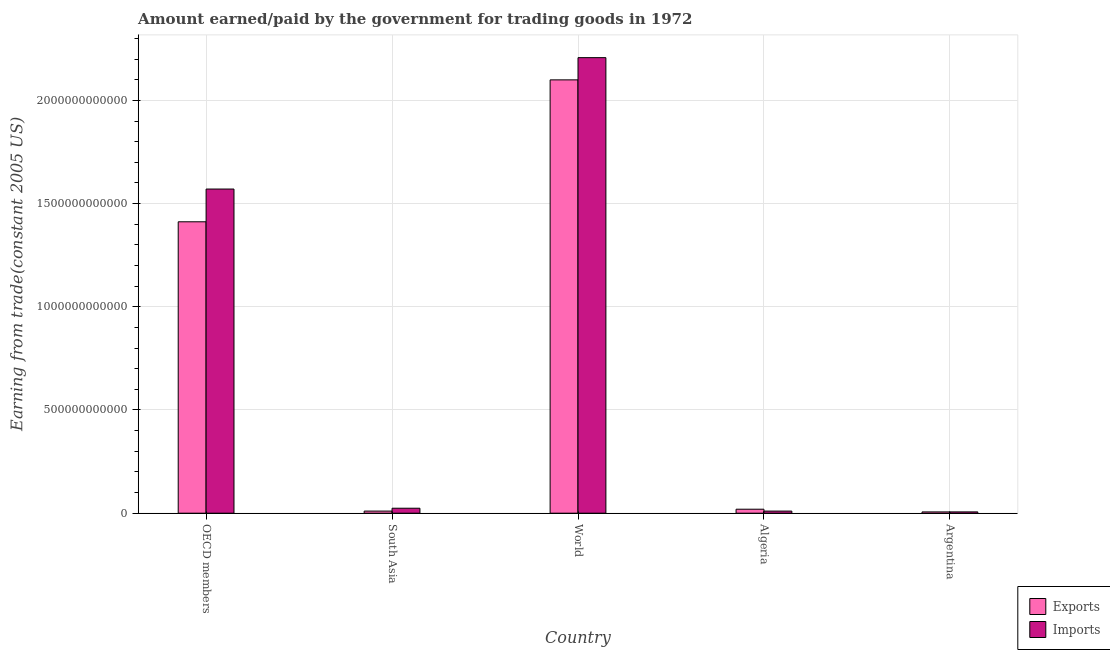Are the number of bars on each tick of the X-axis equal?
Give a very brief answer. Yes. How many bars are there on the 3rd tick from the left?
Keep it short and to the point. 2. How many bars are there on the 1st tick from the right?
Make the answer very short. 2. In how many cases, is the number of bars for a given country not equal to the number of legend labels?
Your response must be concise. 0. What is the amount earned from exports in World?
Provide a short and direct response. 2.10e+12. Across all countries, what is the maximum amount earned from exports?
Make the answer very short. 2.10e+12. Across all countries, what is the minimum amount paid for imports?
Your answer should be compact. 6.34e+09. What is the total amount earned from exports in the graph?
Your response must be concise. 3.55e+12. What is the difference between the amount earned from exports in OECD members and that in South Asia?
Make the answer very short. 1.40e+12. What is the difference between the amount paid for imports in Algeria and the amount earned from exports in World?
Provide a succinct answer. -2.09e+12. What is the average amount earned from exports per country?
Offer a very short reply. 7.09e+11. What is the difference between the amount earned from exports and amount paid for imports in Algeria?
Provide a succinct answer. 9.13e+09. In how many countries, is the amount paid for imports greater than 500000000000 US$?
Ensure brevity in your answer.  2. What is the ratio of the amount paid for imports in OECD members to that in South Asia?
Offer a terse response. 65.22. Is the amount earned from exports in South Asia less than that in World?
Make the answer very short. Yes. What is the difference between the highest and the second highest amount paid for imports?
Keep it short and to the point. 6.37e+11. What is the difference between the highest and the lowest amount paid for imports?
Your answer should be very brief. 2.20e+12. Is the sum of the amount paid for imports in Argentina and OECD members greater than the maximum amount earned from exports across all countries?
Provide a succinct answer. No. What does the 2nd bar from the left in Algeria represents?
Offer a very short reply. Imports. What does the 2nd bar from the right in Argentina represents?
Your answer should be very brief. Exports. How many bars are there?
Your answer should be very brief. 10. Are all the bars in the graph horizontal?
Provide a short and direct response. No. How many countries are there in the graph?
Offer a terse response. 5. What is the difference between two consecutive major ticks on the Y-axis?
Offer a terse response. 5.00e+11. Where does the legend appear in the graph?
Your response must be concise. Bottom right. How are the legend labels stacked?
Your answer should be very brief. Vertical. What is the title of the graph?
Your response must be concise. Amount earned/paid by the government for trading goods in 1972. What is the label or title of the X-axis?
Provide a succinct answer. Country. What is the label or title of the Y-axis?
Provide a succinct answer. Earning from trade(constant 2005 US). What is the Earning from trade(constant 2005 US) in Exports in OECD members?
Provide a succinct answer. 1.41e+12. What is the Earning from trade(constant 2005 US) of Imports in OECD members?
Your response must be concise. 1.57e+12. What is the Earning from trade(constant 2005 US) of Exports in South Asia?
Provide a short and direct response. 1.03e+1. What is the Earning from trade(constant 2005 US) in Imports in South Asia?
Make the answer very short. 2.41e+1. What is the Earning from trade(constant 2005 US) of Exports in World?
Offer a very short reply. 2.10e+12. What is the Earning from trade(constant 2005 US) of Imports in World?
Give a very brief answer. 2.21e+12. What is the Earning from trade(constant 2005 US) in Exports in Algeria?
Ensure brevity in your answer.  1.94e+1. What is the Earning from trade(constant 2005 US) of Imports in Algeria?
Offer a very short reply. 1.02e+1. What is the Earning from trade(constant 2005 US) in Exports in Argentina?
Provide a short and direct response. 6.24e+09. What is the Earning from trade(constant 2005 US) of Imports in Argentina?
Keep it short and to the point. 6.34e+09. Across all countries, what is the maximum Earning from trade(constant 2005 US) of Exports?
Ensure brevity in your answer.  2.10e+12. Across all countries, what is the maximum Earning from trade(constant 2005 US) in Imports?
Your response must be concise. 2.21e+12. Across all countries, what is the minimum Earning from trade(constant 2005 US) of Exports?
Offer a terse response. 6.24e+09. Across all countries, what is the minimum Earning from trade(constant 2005 US) of Imports?
Give a very brief answer. 6.34e+09. What is the total Earning from trade(constant 2005 US) in Exports in the graph?
Offer a very short reply. 3.55e+12. What is the total Earning from trade(constant 2005 US) in Imports in the graph?
Your answer should be compact. 3.82e+12. What is the difference between the Earning from trade(constant 2005 US) of Exports in OECD members and that in South Asia?
Offer a very short reply. 1.40e+12. What is the difference between the Earning from trade(constant 2005 US) of Imports in OECD members and that in South Asia?
Provide a succinct answer. 1.55e+12. What is the difference between the Earning from trade(constant 2005 US) of Exports in OECD members and that in World?
Give a very brief answer. -6.88e+11. What is the difference between the Earning from trade(constant 2005 US) in Imports in OECD members and that in World?
Your response must be concise. -6.37e+11. What is the difference between the Earning from trade(constant 2005 US) in Exports in OECD members and that in Algeria?
Make the answer very short. 1.39e+12. What is the difference between the Earning from trade(constant 2005 US) in Imports in OECD members and that in Algeria?
Your response must be concise. 1.56e+12. What is the difference between the Earning from trade(constant 2005 US) of Exports in OECD members and that in Argentina?
Give a very brief answer. 1.41e+12. What is the difference between the Earning from trade(constant 2005 US) in Imports in OECD members and that in Argentina?
Give a very brief answer. 1.56e+12. What is the difference between the Earning from trade(constant 2005 US) of Exports in South Asia and that in World?
Your response must be concise. -2.09e+12. What is the difference between the Earning from trade(constant 2005 US) of Imports in South Asia and that in World?
Your answer should be very brief. -2.18e+12. What is the difference between the Earning from trade(constant 2005 US) in Exports in South Asia and that in Algeria?
Your answer should be very brief. -9.09e+09. What is the difference between the Earning from trade(constant 2005 US) in Imports in South Asia and that in Algeria?
Keep it short and to the point. 1.39e+1. What is the difference between the Earning from trade(constant 2005 US) in Exports in South Asia and that in Argentina?
Give a very brief answer. 4.02e+09. What is the difference between the Earning from trade(constant 2005 US) in Imports in South Asia and that in Argentina?
Provide a short and direct response. 1.77e+1. What is the difference between the Earning from trade(constant 2005 US) in Exports in World and that in Algeria?
Your answer should be very brief. 2.08e+12. What is the difference between the Earning from trade(constant 2005 US) in Imports in World and that in Algeria?
Provide a short and direct response. 2.20e+12. What is the difference between the Earning from trade(constant 2005 US) in Exports in World and that in Argentina?
Your answer should be compact. 2.09e+12. What is the difference between the Earning from trade(constant 2005 US) of Imports in World and that in Argentina?
Ensure brevity in your answer.  2.20e+12. What is the difference between the Earning from trade(constant 2005 US) in Exports in Algeria and that in Argentina?
Provide a succinct answer. 1.31e+1. What is the difference between the Earning from trade(constant 2005 US) in Imports in Algeria and that in Argentina?
Your answer should be very brief. 3.89e+09. What is the difference between the Earning from trade(constant 2005 US) in Exports in OECD members and the Earning from trade(constant 2005 US) in Imports in South Asia?
Give a very brief answer. 1.39e+12. What is the difference between the Earning from trade(constant 2005 US) of Exports in OECD members and the Earning from trade(constant 2005 US) of Imports in World?
Offer a very short reply. -7.95e+11. What is the difference between the Earning from trade(constant 2005 US) of Exports in OECD members and the Earning from trade(constant 2005 US) of Imports in Algeria?
Give a very brief answer. 1.40e+12. What is the difference between the Earning from trade(constant 2005 US) of Exports in OECD members and the Earning from trade(constant 2005 US) of Imports in Argentina?
Your answer should be very brief. 1.41e+12. What is the difference between the Earning from trade(constant 2005 US) in Exports in South Asia and the Earning from trade(constant 2005 US) in Imports in World?
Your answer should be compact. -2.20e+12. What is the difference between the Earning from trade(constant 2005 US) in Exports in South Asia and the Earning from trade(constant 2005 US) in Imports in Algeria?
Keep it short and to the point. 4.00e+07. What is the difference between the Earning from trade(constant 2005 US) of Exports in South Asia and the Earning from trade(constant 2005 US) of Imports in Argentina?
Give a very brief answer. 3.93e+09. What is the difference between the Earning from trade(constant 2005 US) of Exports in World and the Earning from trade(constant 2005 US) of Imports in Algeria?
Your answer should be compact. 2.09e+12. What is the difference between the Earning from trade(constant 2005 US) in Exports in World and the Earning from trade(constant 2005 US) in Imports in Argentina?
Provide a short and direct response. 2.09e+12. What is the difference between the Earning from trade(constant 2005 US) of Exports in Algeria and the Earning from trade(constant 2005 US) of Imports in Argentina?
Keep it short and to the point. 1.30e+1. What is the average Earning from trade(constant 2005 US) in Exports per country?
Your answer should be compact. 7.09e+11. What is the average Earning from trade(constant 2005 US) of Imports per country?
Your response must be concise. 7.64e+11. What is the difference between the Earning from trade(constant 2005 US) in Exports and Earning from trade(constant 2005 US) in Imports in OECD members?
Offer a terse response. -1.59e+11. What is the difference between the Earning from trade(constant 2005 US) of Exports and Earning from trade(constant 2005 US) of Imports in South Asia?
Ensure brevity in your answer.  -1.38e+1. What is the difference between the Earning from trade(constant 2005 US) of Exports and Earning from trade(constant 2005 US) of Imports in World?
Offer a terse response. -1.08e+11. What is the difference between the Earning from trade(constant 2005 US) in Exports and Earning from trade(constant 2005 US) in Imports in Algeria?
Offer a very short reply. 9.13e+09. What is the difference between the Earning from trade(constant 2005 US) of Exports and Earning from trade(constant 2005 US) of Imports in Argentina?
Ensure brevity in your answer.  -9.74e+07. What is the ratio of the Earning from trade(constant 2005 US) of Exports in OECD members to that in South Asia?
Provide a short and direct response. 137.5. What is the ratio of the Earning from trade(constant 2005 US) in Imports in OECD members to that in South Asia?
Your answer should be compact. 65.22. What is the ratio of the Earning from trade(constant 2005 US) of Exports in OECD members to that in World?
Your answer should be very brief. 0.67. What is the ratio of the Earning from trade(constant 2005 US) of Imports in OECD members to that in World?
Offer a terse response. 0.71. What is the ratio of the Earning from trade(constant 2005 US) in Exports in OECD members to that in Algeria?
Offer a terse response. 72.93. What is the ratio of the Earning from trade(constant 2005 US) of Imports in OECD members to that in Algeria?
Offer a very short reply. 153.56. What is the ratio of the Earning from trade(constant 2005 US) in Exports in OECD members to that in Argentina?
Provide a short and direct response. 226.15. What is the ratio of the Earning from trade(constant 2005 US) in Imports in OECD members to that in Argentina?
Offer a very short reply. 247.71. What is the ratio of the Earning from trade(constant 2005 US) of Exports in South Asia to that in World?
Offer a very short reply. 0. What is the ratio of the Earning from trade(constant 2005 US) in Imports in South Asia to that in World?
Your answer should be compact. 0.01. What is the ratio of the Earning from trade(constant 2005 US) of Exports in South Asia to that in Algeria?
Make the answer very short. 0.53. What is the ratio of the Earning from trade(constant 2005 US) in Imports in South Asia to that in Algeria?
Provide a succinct answer. 2.35. What is the ratio of the Earning from trade(constant 2005 US) of Exports in South Asia to that in Argentina?
Keep it short and to the point. 1.64. What is the ratio of the Earning from trade(constant 2005 US) in Imports in South Asia to that in Argentina?
Offer a terse response. 3.8. What is the ratio of the Earning from trade(constant 2005 US) in Exports in World to that in Algeria?
Your answer should be compact. 108.46. What is the ratio of the Earning from trade(constant 2005 US) in Imports in World to that in Algeria?
Keep it short and to the point. 215.8. What is the ratio of the Earning from trade(constant 2005 US) in Exports in World to that in Argentina?
Give a very brief answer. 336.3. What is the ratio of the Earning from trade(constant 2005 US) in Imports in World to that in Argentina?
Your response must be concise. 348.11. What is the ratio of the Earning from trade(constant 2005 US) of Exports in Algeria to that in Argentina?
Keep it short and to the point. 3.1. What is the ratio of the Earning from trade(constant 2005 US) of Imports in Algeria to that in Argentina?
Offer a terse response. 1.61. What is the difference between the highest and the second highest Earning from trade(constant 2005 US) of Exports?
Keep it short and to the point. 6.88e+11. What is the difference between the highest and the second highest Earning from trade(constant 2005 US) of Imports?
Your answer should be very brief. 6.37e+11. What is the difference between the highest and the lowest Earning from trade(constant 2005 US) in Exports?
Your response must be concise. 2.09e+12. What is the difference between the highest and the lowest Earning from trade(constant 2005 US) of Imports?
Give a very brief answer. 2.20e+12. 